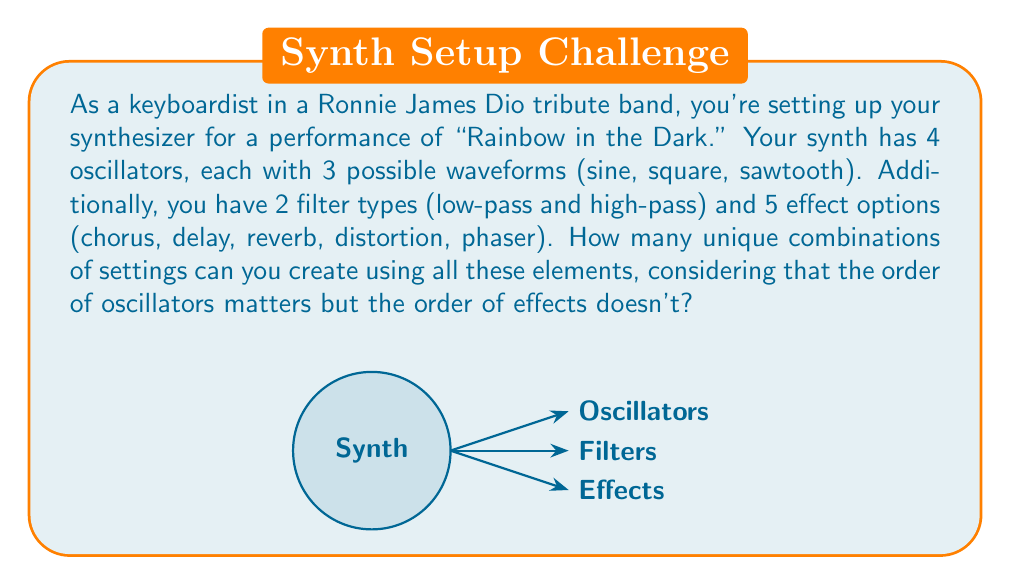Can you answer this question? Let's break this down step-by-step:

1) First, let's consider the oscillators:
   - We have 4 oscillators, each with 3 possible waveforms.
   - The order of oscillators matters, so this is a permutation with repetition.
   - The number of possibilities for oscillators is $3^4 = 81$.

2) For the filters:
   - We have 2 filter types to choose from.
   - This is a simple binary choice, so it's just 2 possibilities.

3) For the effects:
   - We have 5 effect options.
   - The order doesn't matter, but we can use any number of effects (including none or all).
   - This is equivalent to finding the number of subsets of a 5-element set.
   - The number of subsets is $2^5 = 32$.

4) Now, we apply the multiplication principle:
   - Each choice is independent, so we multiply the number of possibilities.
   - Total combinations = (Oscillator combinations) × (Filter choices) × (Effect combinations)
   
   $$ 81 \times 2 \times 32 = 5,184 $$

Therefore, the total number of unique combinations is 5,184.
Answer: 5,184 